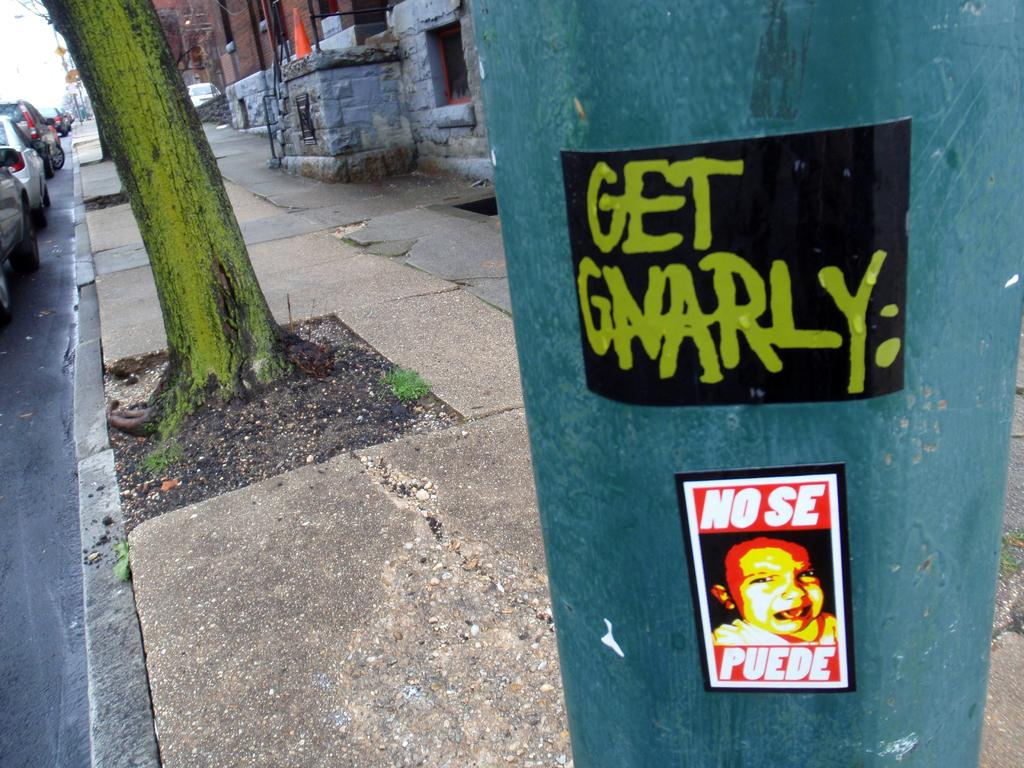<image>
Summarize the visual content of the image. a post that has the words get gnarly written on it 